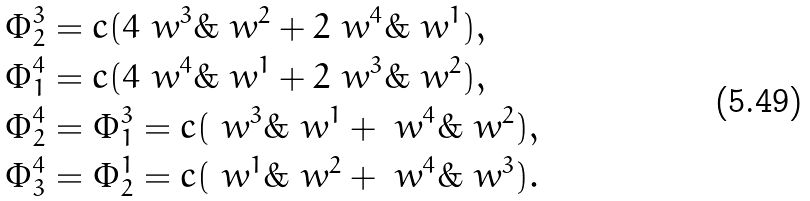Convert formula to latex. <formula><loc_0><loc_0><loc_500><loc_500>\Phi ^ { 3 } _ { 2 } & = c ( 4 \ w ^ { 3 } \& \ w ^ { 2 } + 2 \ w ^ { 4 } \& \ w ^ { 1 } ) , \\ \Phi ^ { 4 } _ { 1 } & = c ( 4 \ w ^ { 4 } \& \ w ^ { 1 } + 2 \ w ^ { 3 } \& \ w ^ { 2 } ) , \\ \Phi ^ { 4 } _ { 2 } & = \Phi ^ { 3 } _ { 1 } = c ( \ w ^ { 3 } \& \ w ^ { 1 } + \ w ^ { 4 } \& \ w ^ { 2 } ) , \\ \Phi ^ { 4 } _ { 3 } & = \Phi ^ { 1 } _ { 2 } = c ( \ w ^ { 1 } \& \ w ^ { 2 } + \ w ^ { 4 } \& \ w ^ { 3 } ) . \\</formula> 